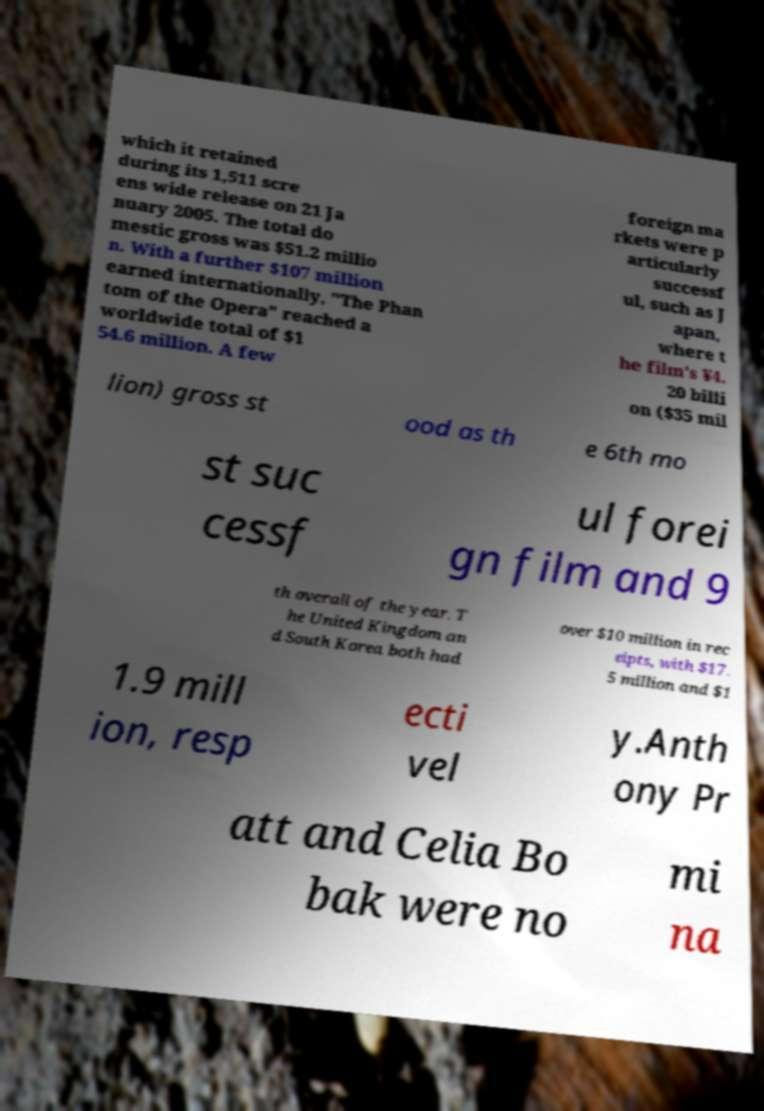Could you assist in decoding the text presented in this image and type it out clearly? which it retained during its 1,511 scre ens wide release on 21 Ja nuary 2005. The total do mestic gross was $51.2 millio n. With a further $107 million earned internationally, "The Phan tom of the Opera" reached a worldwide total of $1 54.6 million. A few foreign ma rkets were p articularly successf ul, such as J apan, where t he film's ¥4. 20 billi on ($35 mil lion) gross st ood as th e 6th mo st suc cessf ul forei gn film and 9 th overall of the year. T he United Kingdom an d South Korea both had over $10 million in rec eipts, with $17. 5 million and $1 1.9 mill ion, resp ecti vel y.Anth ony Pr att and Celia Bo bak were no mi na 